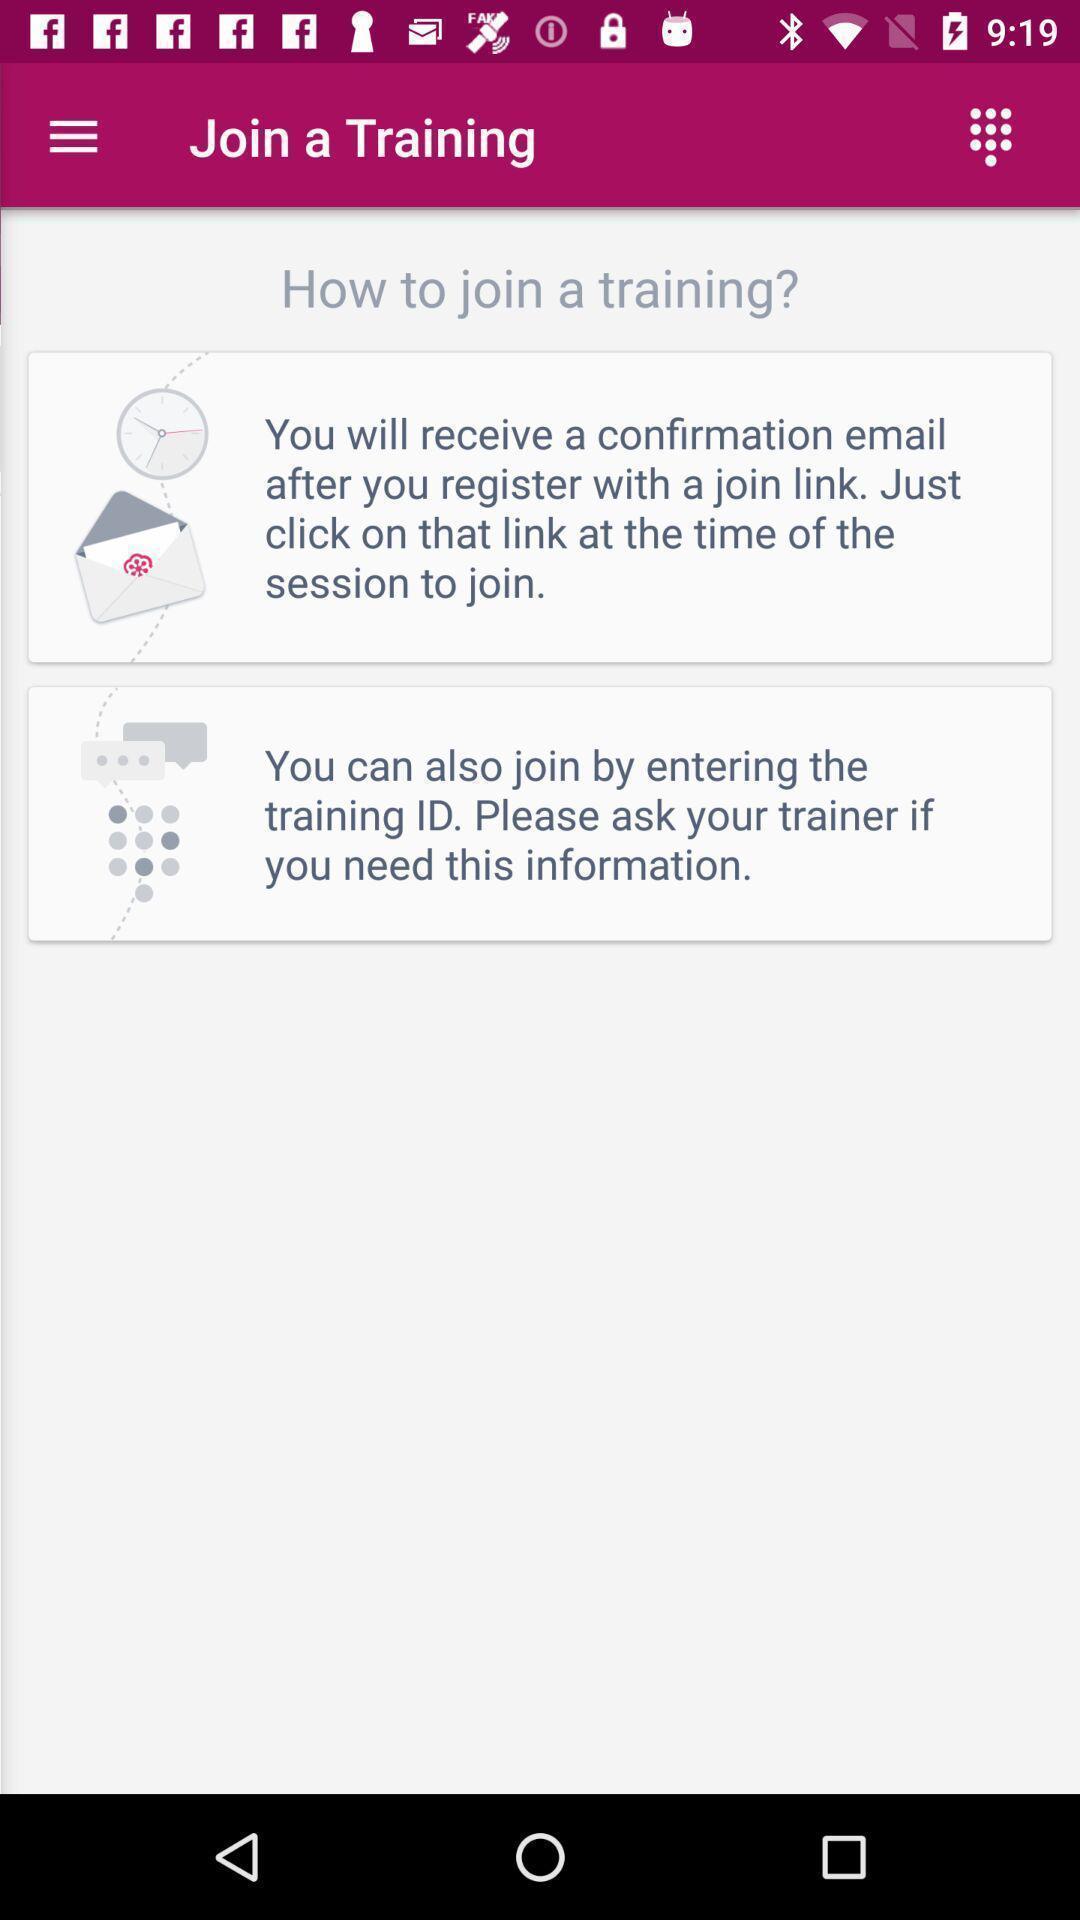Describe the content in this image. Screen shows how to join a training. 